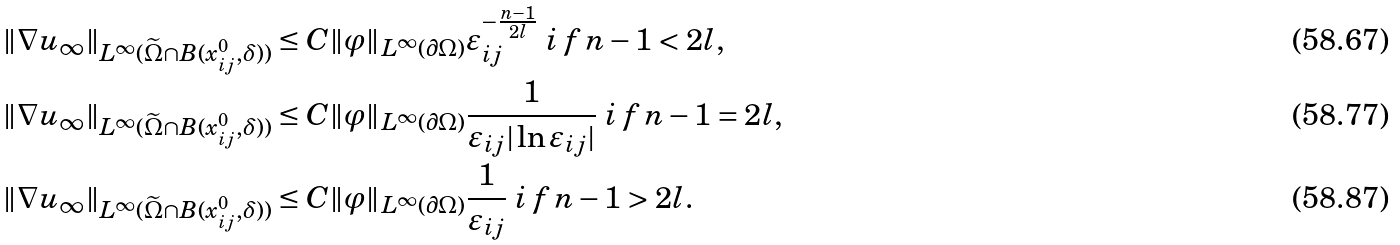<formula> <loc_0><loc_0><loc_500><loc_500>& \| \nabla u _ { \infty } \| _ { L ^ { \infty } ( \widetilde { \Omega } \cap B ( x ^ { 0 } _ { i j } , \delta ) ) } \leq C \| \varphi \| _ { L ^ { \infty } ( \partial \Omega ) } \varepsilon _ { i j } ^ { - \frac { n - 1 } { 2 l } } \emph { i f } n - 1 < 2 l , \\ & \| \nabla u _ { \infty } \| _ { L ^ { \infty } ( \widetilde { \Omega } \cap B ( x ^ { 0 } _ { i j } , \delta ) ) } \leq C \| \varphi \| _ { L ^ { \infty } ( \partial \Omega ) } \frac { 1 } { \varepsilon _ { i j } | \ln \varepsilon _ { i j } | } \emph { i f } n - 1 = 2 l , \\ & \| \nabla u _ { \infty } \| _ { L ^ { \infty } ( \widetilde { \Omega } \cap B ( x ^ { 0 } _ { i j } , \delta ) ) } \leq C \| \varphi \| _ { L ^ { \infty } ( \partial \Omega ) } \frac { 1 } { \varepsilon _ { i j } } \emph { i f } n - 1 > 2 l .</formula> 